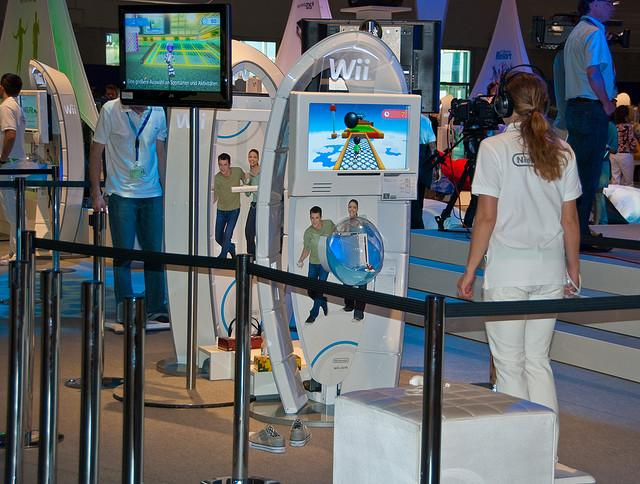What is the article of clothing at the base of the console used for?

Choices:
A) bulletproofing
B) holding weights
C) protect eyes
D) walking walking 